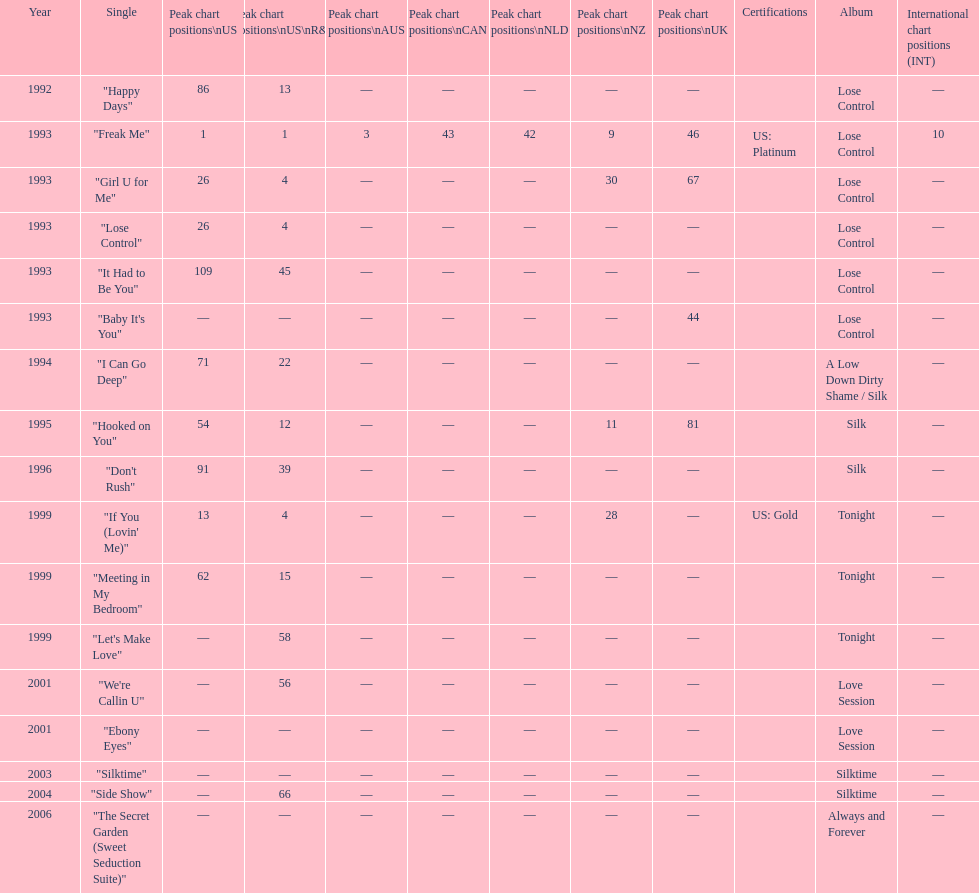Which single is the most in terms of how many times it charted? "Freak Me". 